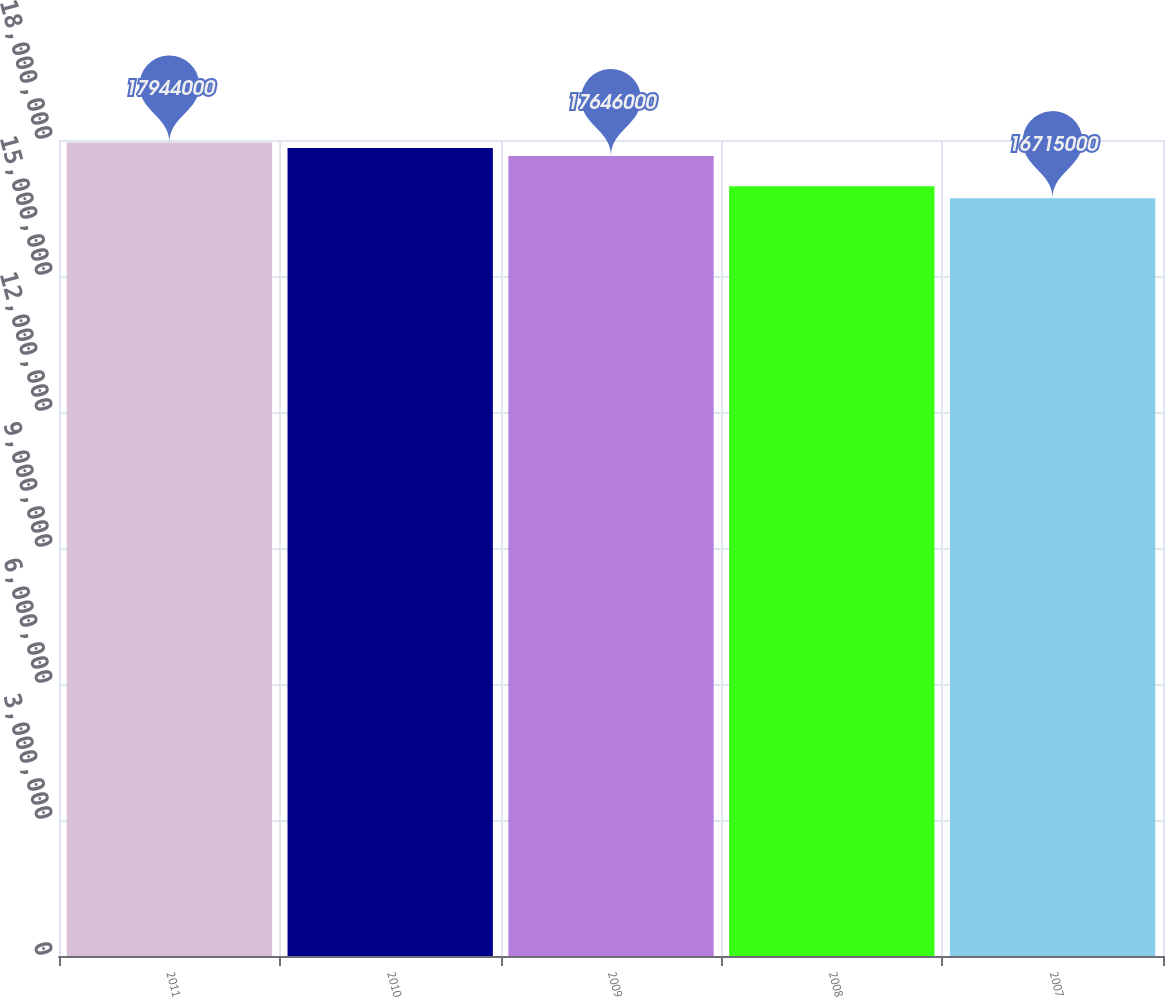Convert chart. <chart><loc_0><loc_0><loc_500><loc_500><bar_chart><fcel>2011<fcel>2010<fcel>2009<fcel>2008<fcel>2007<nl><fcel>1.7944e+07<fcel>1.7823e+07<fcel>1.7646e+07<fcel>1.6981e+07<fcel>1.6715e+07<nl></chart> 